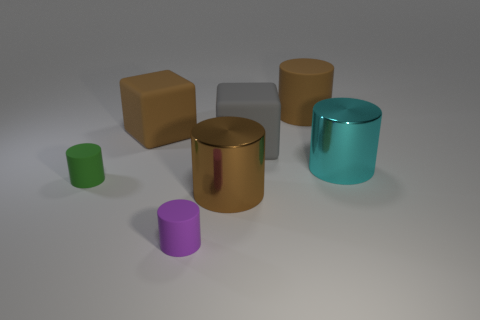There is a large matte object that is the same shape as the tiny purple thing; what color is it?
Keep it short and to the point. Brown. There is a brown cylinder that is in front of the brown rubber block; what size is it?
Your answer should be very brief. Large. Are there any matte blocks that have the same color as the big matte cylinder?
Offer a terse response. Yes. Is there a big metal object in front of the big thing in front of the cyan metallic cylinder?
Give a very brief answer. No. There is a cyan thing; is its size the same as the shiny object that is in front of the small green thing?
Your answer should be very brief. Yes. Are there any big gray rubber things right of the large brown thing right of the large brown cylinder in front of the big cyan shiny cylinder?
Your answer should be very brief. No. What is the material of the brown cylinder behind the green object?
Make the answer very short. Rubber. Is the brown block the same size as the gray matte cube?
Your answer should be compact. Yes. The object that is in front of the large cyan metallic cylinder and on the right side of the purple rubber cylinder is what color?
Provide a short and direct response. Brown. What shape is the large gray object that is made of the same material as the large brown block?
Offer a very short reply. Cube. 